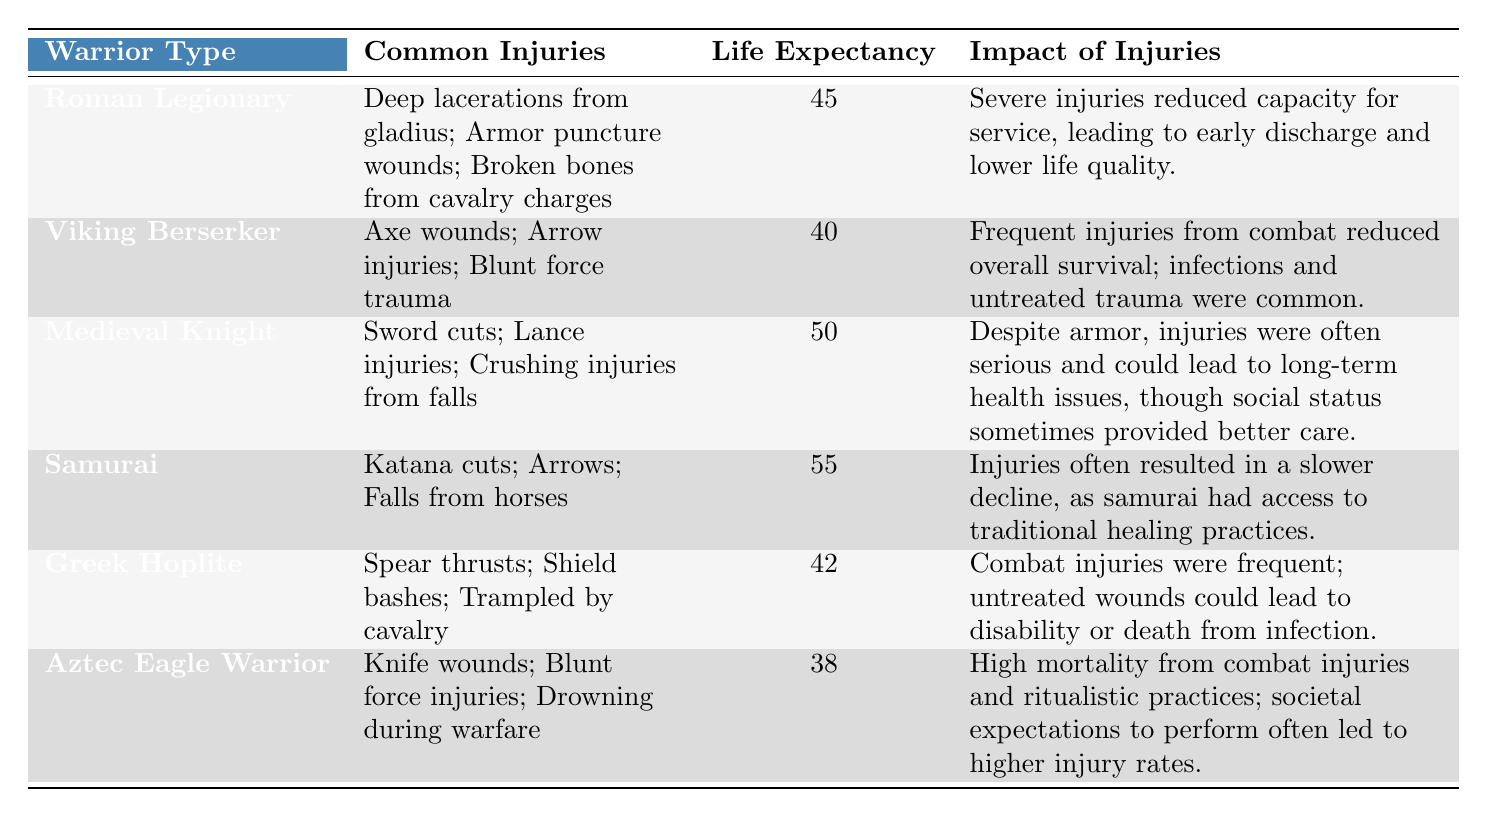What is the average life expectancy of the Medieval Knight? The table shows that the average life expectancy for the Medieval Knight is listed as 50.
Answer: 50 Which warrior type has the highest average life expectancy? By examining the life expectancies in the table, the Samurai has the highest average life expectancy at 55.
Answer: 55 Is it true that the Aztec Eagle Warrior has a life expectancy greater than 40? The life expectancy for the Aztec Eagle Warrior is 38, which is less than 40. Therefore, the statement is false.
Answer: No What is the difference in life expectancy between the Roman Legionary and the Greek Hoplite? The Roman Legionary has a life expectancy of 45, while the Greek Hoplite has 42. The difference is 45 - 42 = 3.
Answer: 3 How many types of common injuries do Viking Berserkers have listed in the table? The Viking Berserker has three common injuries listed: Axe wounds, Arrow injuries, and Blunt force trauma.
Answer: 3 Which warrior type has common injuries from cavalry charges? The Roman Legionary is the only warrior type mentioned that has common injuries from cavalry charges.
Answer: Roman Legionary If the average life expectancy of all six warrior types is calculated, what would it be? The life expectancies listed are 45, 40, 50, 55, 42, and 38. The sum is 270, and dividing by 6 gives an average of 270 / 6 = 45.
Answer: 45 What is the impact of injuries on the Samurai compared to the Viking Berserker? The Samurai's injuries often led to a slower decline due to access to healing practices, while the Viking Berserker's injuries from combat reduced overall survival. This indicates a significant difference in recovery and quality of life after injuries.
Answer: Samurai has better recovery due to access to healing practices Is the average life expectancy of the Greek Hoplite above or below 45? The average life expectancy of the Greek Hoplite is 42, which is below 45.
Answer: Below 45 